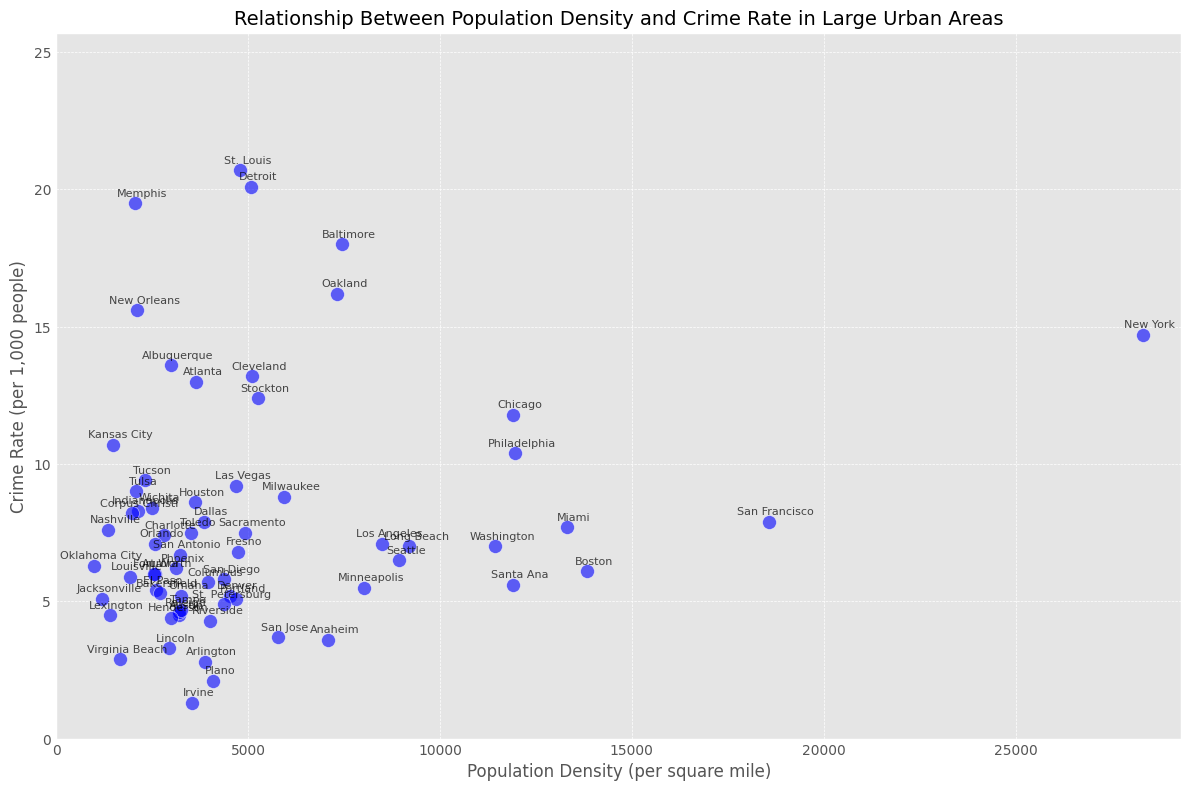Which city has the highest crime rate? By observing the scatter plot, identify the point that indicates the highest position on the vertical axis (Crime Rate). The plot should have each point annotated with the corresponding city names.
Answer: St. Louis Which city has the lowest population density? Look for the point that is positioned the furthest to the left on the horizontal axis (Population Density). The point with the smallest x-value corresponds to the city with the lowest population density.
Answer: Oklahoma City Which city has a higher crime rate: Albuquerque or Las Vegas? Locate the points for Albuquerque and Las Vegas on the scatter plot and compare their vertical positions. The point higher on the y-axis represents the city with a higher crime rate.
Answer: Albuquerque Does New York or Los Angeles have a higher population density? Find the points representing New York and Los Angeles and compare their horizontal positions. The point further to the right on the x-axis corresponds to the city with the higher population density.
Answer: New York What's the general relationship trend between population density and crime rate based on the scatter plot? Examine the overall distribution of points in the plot. Observe if there are more points concentrated in any particular area or forming a pattern (e.g., upward trend, downward trend, or no clear trend).
Answer: Generally positive trend Which city has a similar crime rate to Miami but a much lower population density? Identify the point representing Miami and find another point with a similar y-value (crime rate) but a significantly lower x-value (population density).
Answer: Baltimore How many cities have a crime rate above 15 per 1,000 people? Count the number of points positioned above the y-value of 15 on the vertical axis. Each point represents a city.
Answer: 4 Is there any notable outlier in terms of crime rate? Look for points that are significantly higher or lower in comparison to other points in the plot. These outliers will be noticeably separated vertically from the main cluster of points.
Answer: St. Louis What is the crime rate difference between the cities with the highest and lowest population densities? Identify the cities with the highest and lowest population densities. Note their crime rates and calculate the difference.
Answer: 12.4 Do cities with low population density (below 5,000 per square mile) generally have lower crime rates compared to those with high population density? Observe the concentration of points with x-values below 5,000 and compare their y-values to points with x-values above 5,000. Consider if lower population density areas have generally lower crime rates.
Answer: Generally yes 